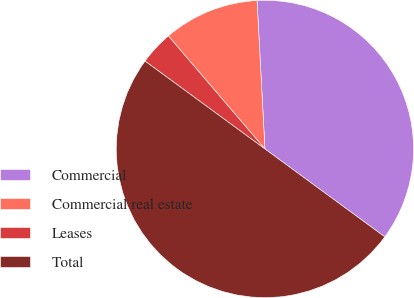Convert chart to OTSL. <chart><loc_0><loc_0><loc_500><loc_500><pie_chart><fcel>Commercial<fcel>Commercial real estate<fcel>Leases<fcel>Total<nl><fcel>35.92%<fcel>10.41%<fcel>3.68%<fcel>50.0%<nl></chart> 